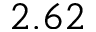<formula> <loc_0><loc_0><loc_500><loc_500>2 . 6 2</formula> 